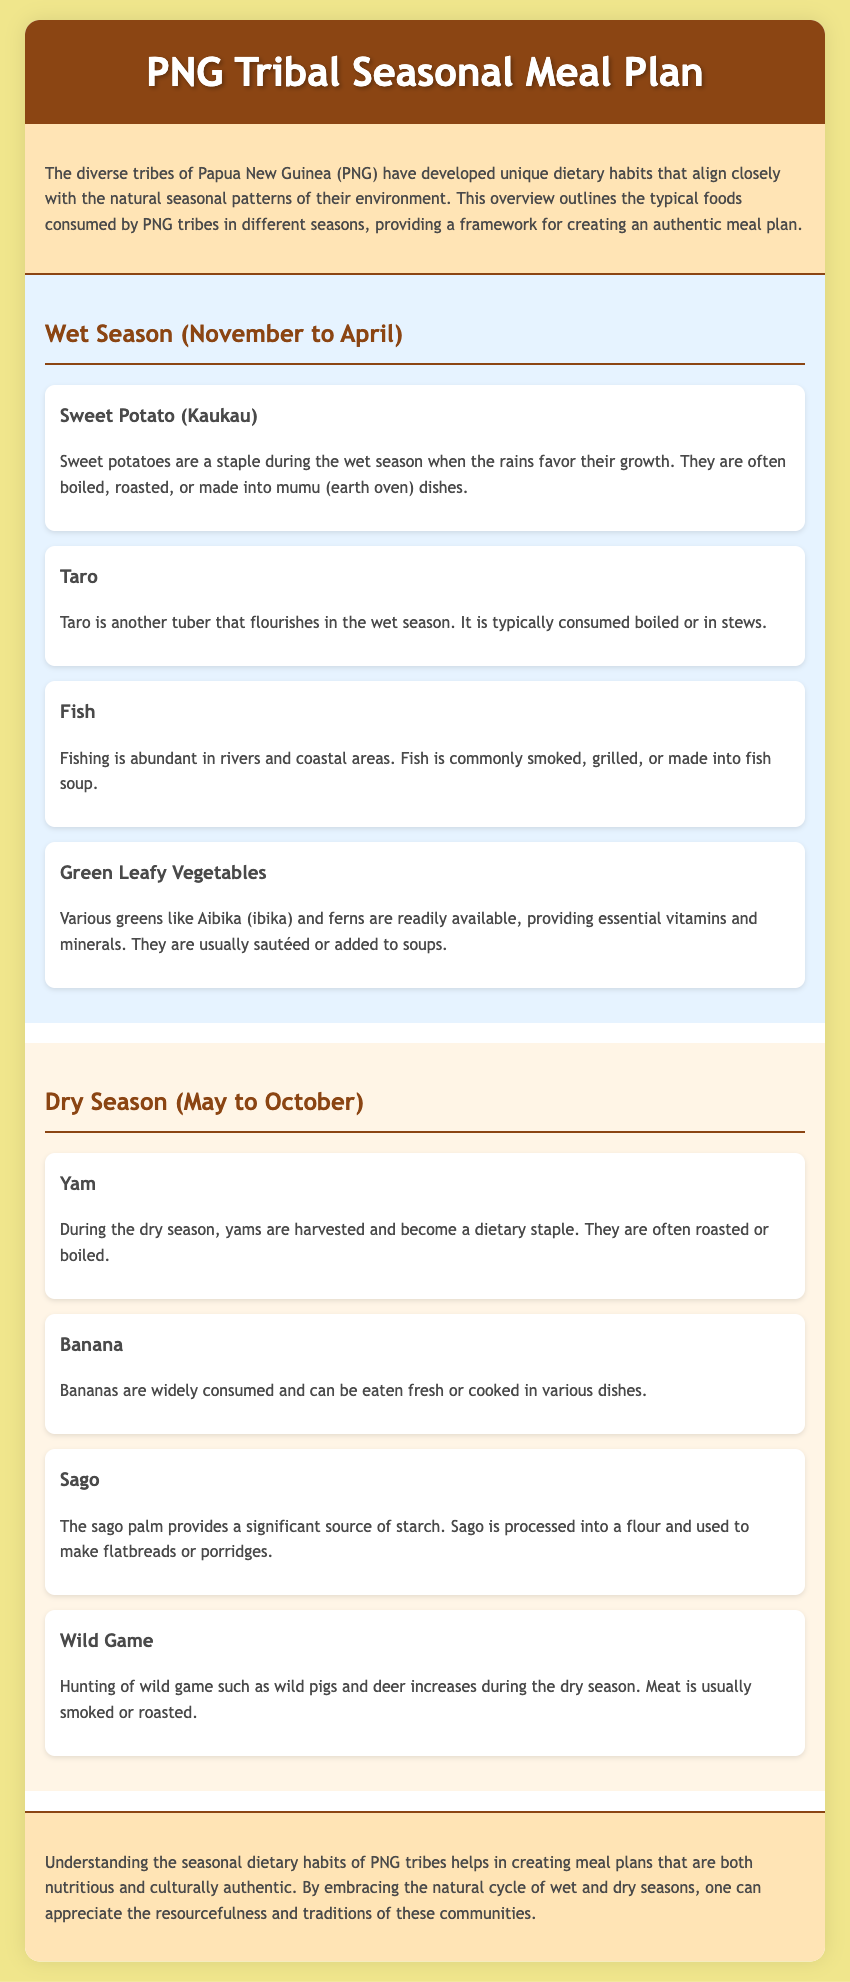What are the main staples during the wet season? The wet season staples include Sweet Potato, Taro, Fish, and Green Leafy Vegetables as detailed in the document.
Answer: Sweet Potato, Taro, Fish, Green Leafy Vegetables How long does the wet season last in PNG? The document specifies that the wet season lasts from November to April.
Answer: November to April What is a commonly prepared dish using Sweet Potato? The document states that Sweet Potato is often made into mumu (earth oven) dishes among other cooking methods.
Answer: Mumu (earth oven) dishes Which starch source is highlighted during the dry season? Sago is identified in the document as a significant source of starch during the dry season.
Answer: Sago What type of game is primarily hunted in the dry season? The document mentions that wild pigs and deer are hunted during the dry season.
Answer: Wild pigs and deer What signifies the transition of dietary habits in PNG tribes? The document emphasizes the shift in dietary staples from wet to dry season, highlighting seasonal resourcefulness.
Answer: Seasonal resourcefulness How are Green Leafy Vegetables typically prepared? According to the document, Green Leafy Vegetables are usually sautéed or added to soups.
Answer: Sautéed or added to soups What is the primary way fish is consumed in PNG during the wet season? The document states that fish is commonly smoked, grilled, or made into fish soup during the wet season.
Answer: Smoked, grilled, or made into fish soup What type of banana consumption is mentioned? The document notes that bananas can be eaten fresh or cooked in various dishes.
Answer: Fresh or cooked in various dishes 